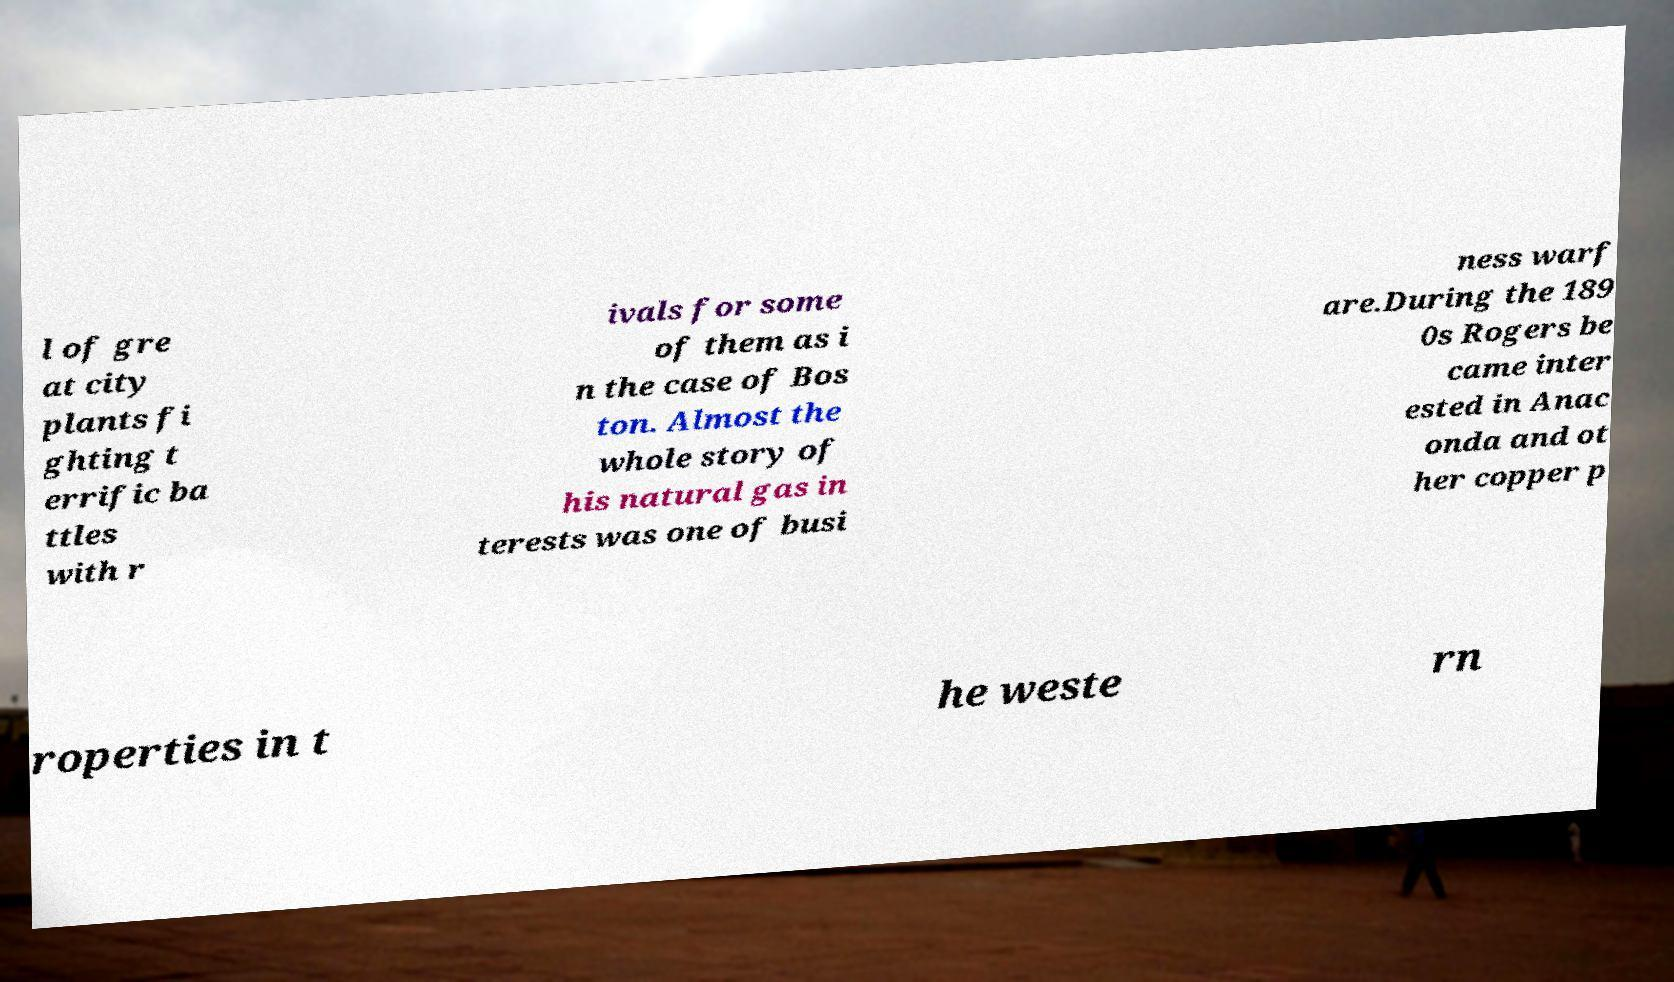Could you assist in decoding the text presented in this image and type it out clearly? l of gre at city plants fi ghting t errific ba ttles with r ivals for some of them as i n the case of Bos ton. Almost the whole story of his natural gas in terests was one of busi ness warf are.During the 189 0s Rogers be came inter ested in Anac onda and ot her copper p roperties in t he weste rn 